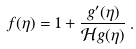<formula> <loc_0><loc_0><loc_500><loc_500>f ( \eta ) = 1 + \frac { g ^ { \prime } ( \eta ) } { { \mathcal { H } } g ( \eta ) } \, .</formula> 